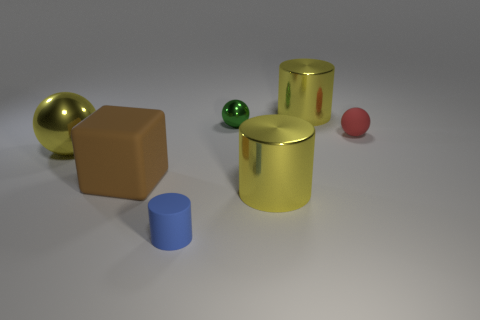Are there fewer blue matte objects that are right of the blue cylinder than tiny brown metal things?
Your answer should be compact. No. Do the yellow sphere and the green sphere that is behind the tiny blue matte cylinder have the same material?
Ensure brevity in your answer.  Yes. What is the tiny red object made of?
Make the answer very short. Rubber. There is a yellow object that is behind the small metallic sphere that is left of the metallic cylinder that is behind the large block; what is it made of?
Your response must be concise. Metal. There is a rubber cylinder; does it have the same color as the matte block on the right side of the large shiny ball?
Your answer should be compact. No. Are there any other things that are the same shape as the green object?
Provide a succinct answer. Yes. What is the color of the tiny matte object right of the big cylinder that is in front of the tiny green sphere?
Ensure brevity in your answer.  Red. How many tiny shiny things are there?
Your response must be concise. 1. How many metal objects are tiny spheres or spheres?
Your answer should be very brief. 2. What number of small balls have the same color as the matte cylinder?
Give a very brief answer. 0. 